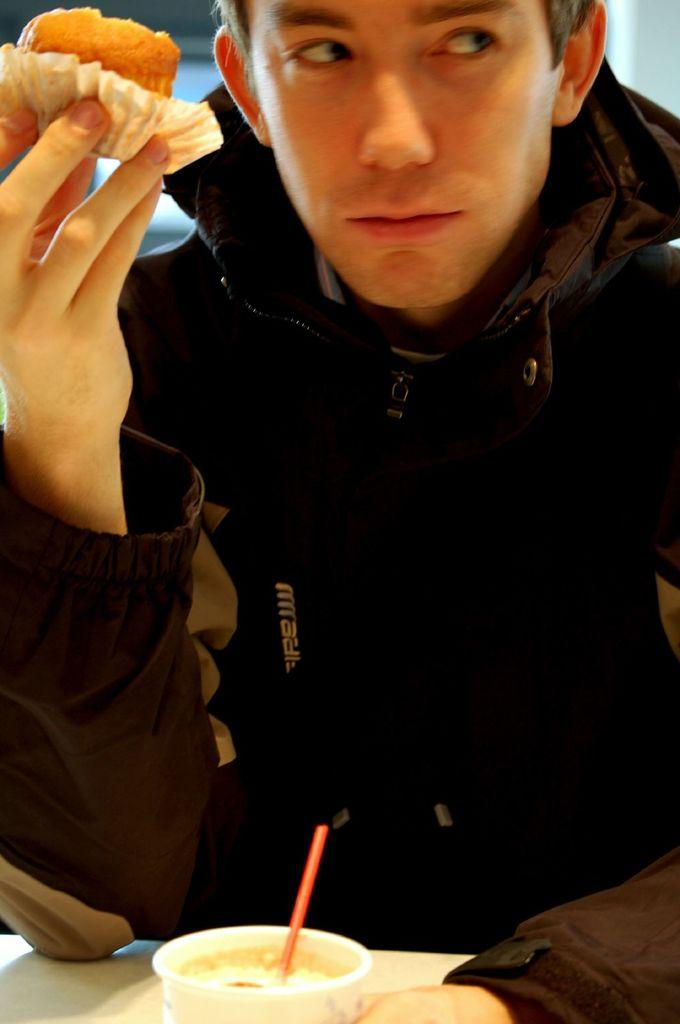Who is present in the image? There is a person in the image. What is the person holding? The person is holding a cupcake. What type of clothing is the person wearing? The person is wearing a coat. What else can be seen on the table in the image? There is a cup on the table in the image. What type of sheet is covering the    table in the image? There is no sheet present in the image; the table has a cup and a cupcake on it. 